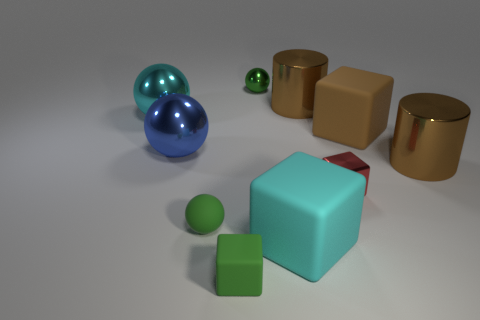Is there another sphere of the same color as the small metallic ball?
Make the answer very short. Yes. There is a sphere that is the same size as the blue object; what is its color?
Keep it short and to the point. Cyan. The small rubber object behind the big matte cube that is in front of the matte thing that is behind the blue sphere is what shape?
Provide a succinct answer. Sphere. What number of large brown things are behind the rubber cube right of the cyan cube?
Your response must be concise. 1. Does the cyan object that is behind the blue sphere have the same shape as the tiny object that is behind the tiny red block?
Provide a succinct answer. Yes. What number of blue balls are in front of the big cyan matte object?
Your response must be concise. 0. Is the material of the tiny thing that is right of the big cyan matte object the same as the small green cube?
Make the answer very short. No. There is another small rubber thing that is the same shape as the brown rubber object; what color is it?
Your answer should be compact. Green. There is a blue thing; what shape is it?
Provide a succinct answer. Sphere. What number of objects are large brown cubes or cyan balls?
Offer a terse response. 2. 